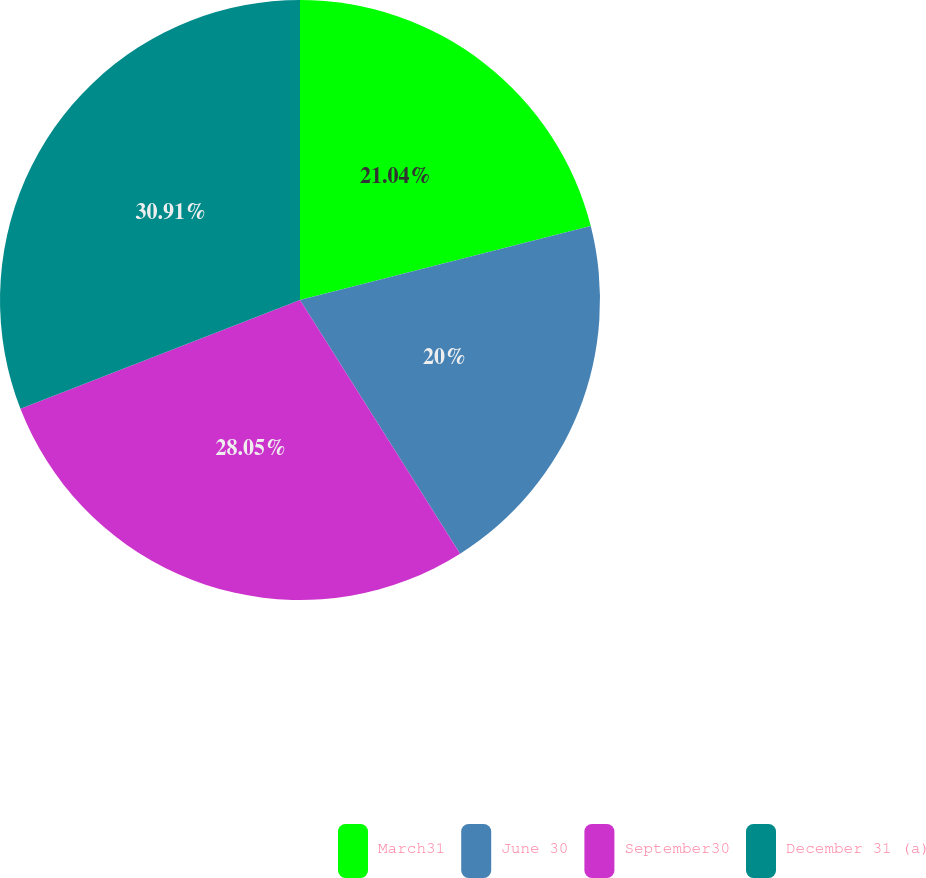Convert chart to OTSL. <chart><loc_0><loc_0><loc_500><loc_500><pie_chart><fcel>March31<fcel>June 30<fcel>September30<fcel>December 31 (a)<nl><fcel>21.04%<fcel>20.0%<fcel>28.05%<fcel>30.91%<nl></chart> 